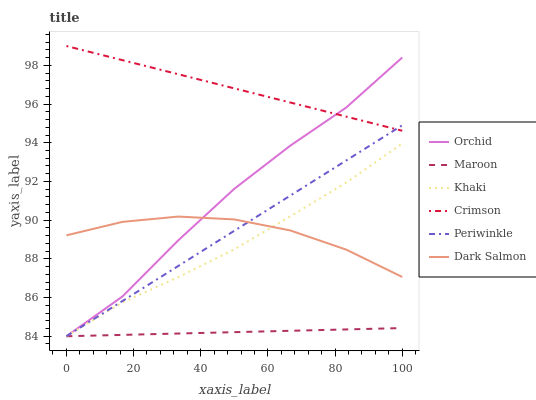Does Maroon have the minimum area under the curve?
Answer yes or no. Yes. Does Crimson have the maximum area under the curve?
Answer yes or no. Yes. Does Dark Salmon have the minimum area under the curve?
Answer yes or no. No. Does Dark Salmon have the maximum area under the curve?
Answer yes or no. No. Is Periwinkle the smoothest?
Answer yes or no. Yes. Is Orchid the roughest?
Answer yes or no. Yes. Is Dark Salmon the smoothest?
Answer yes or no. No. Is Dark Salmon the roughest?
Answer yes or no. No. Does Khaki have the lowest value?
Answer yes or no. Yes. Does Dark Salmon have the lowest value?
Answer yes or no. No. Does Crimson have the highest value?
Answer yes or no. Yes. Does Dark Salmon have the highest value?
Answer yes or no. No. Is Khaki less than Crimson?
Answer yes or no. Yes. Is Crimson greater than Khaki?
Answer yes or no. Yes. Does Dark Salmon intersect Periwinkle?
Answer yes or no. Yes. Is Dark Salmon less than Periwinkle?
Answer yes or no. No. Is Dark Salmon greater than Periwinkle?
Answer yes or no. No. Does Khaki intersect Crimson?
Answer yes or no. No. 